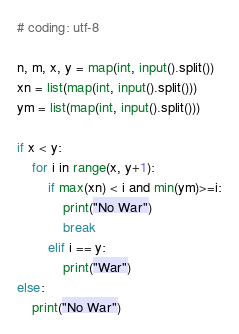<code> <loc_0><loc_0><loc_500><loc_500><_Python_># coding: utf-8
 
n, m, x, y = map(int, input().split())
xn = list(map(int, input().split()))
ym = list(map(int, input().split()))

if x < y:
    for i in range(x, y+1):
        if max(xn) < i and min(ym)>=i:
            print("No War")
            break
        elif i == y:
            print("War")
else:
    print("No War")</code> 